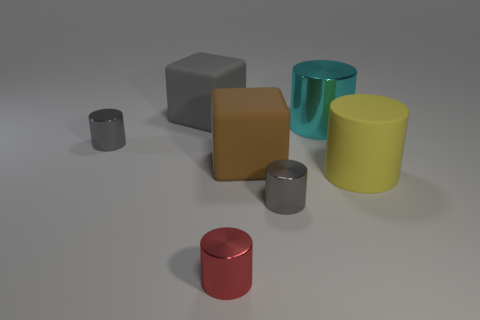Subtract all yellow cylinders. How many cylinders are left? 4 Add 2 tiny things. How many objects exist? 9 Subtract all red cylinders. How many cylinders are left? 4 Subtract all cylinders. How many objects are left? 2 Subtract 5 cylinders. How many cylinders are left? 0 Subtract all small gray objects. Subtract all small red things. How many objects are left? 4 Add 1 yellow cylinders. How many yellow cylinders are left? 2 Add 1 metallic things. How many metallic things exist? 5 Subtract 1 cyan cylinders. How many objects are left? 6 Subtract all cyan cylinders. Subtract all red spheres. How many cylinders are left? 4 